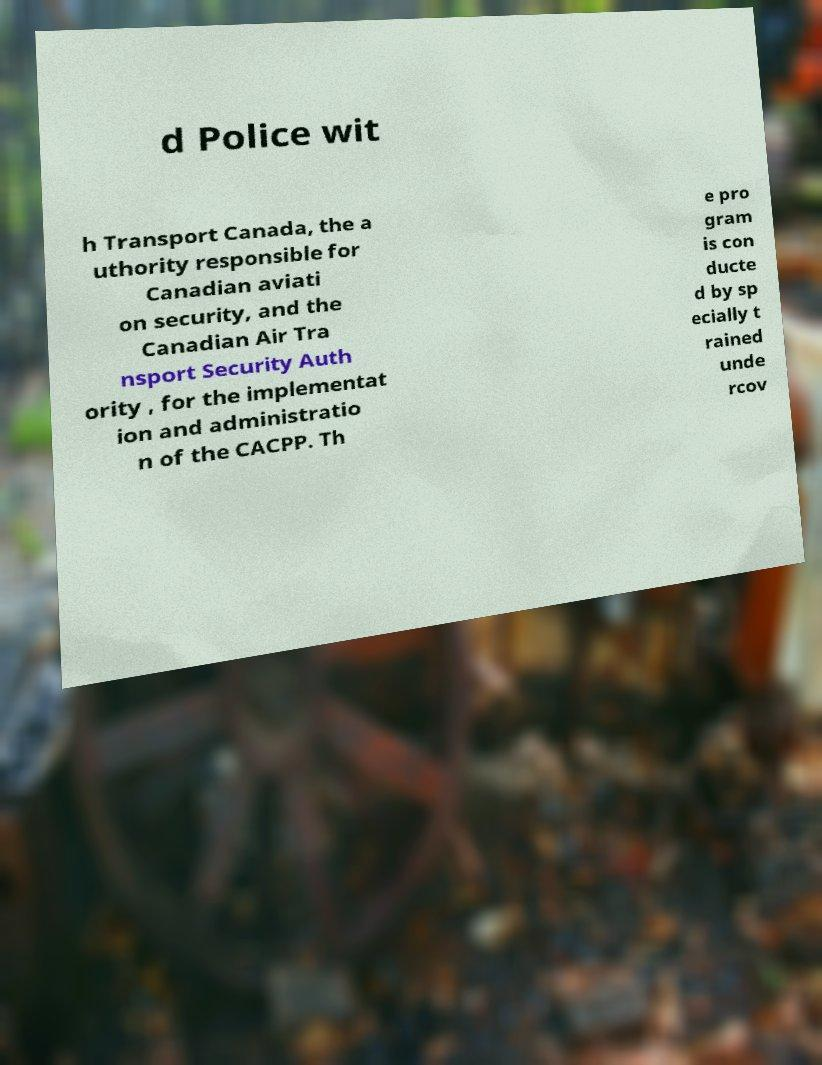I need the written content from this picture converted into text. Can you do that? d Police wit h Transport Canada, the a uthority responsible for Canadian aviati on security, and the Canadian Air Tra nsport Security Auth ority , for the implementat ion and administratio n of the CACPP. Th e pro gram is con ducte d by sp ecially t rained unde rcov 